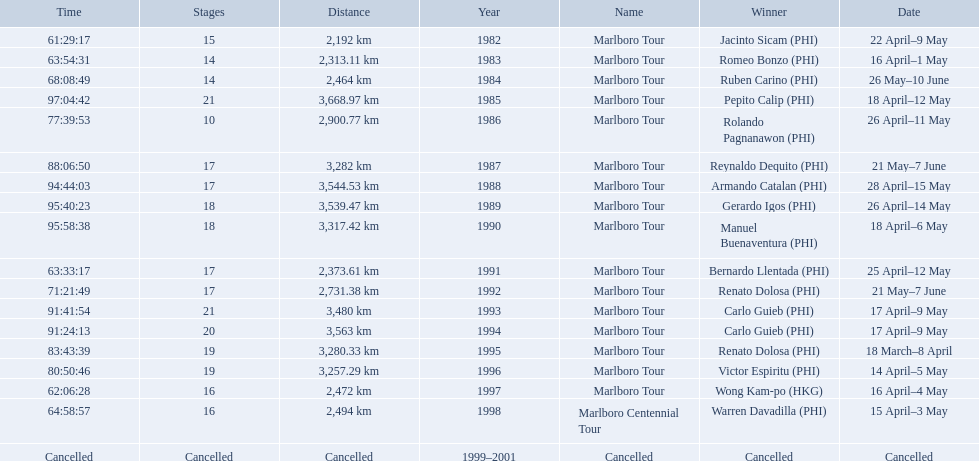What race did warren davadilla compete in in 1998? Marlboro Centennial Tour. Would you mind parsing the complete table? {'header': ['Time', 'Stages', 'Distance', 'Year', 'Name', 'Winner', 'Date'], 'rows': [['61:29:17', '15', '2,192\xa0km', '1982', 'Marlboro Tour', 'Jacinto Sicam\xa0(PHI)', '22 April–9 May'], ['63:54:31', '14', '2,313.11\xa0km', '1983', 'Marlboro Tour', 'Romeo Bonzo\xa0(PHI)', '16 April–1 May'], ['68:08:49', '14', '2,464\xa0km', '1984', 'Marlboro Tour', 'Ruben Carino\xa0(PHI)', '26 May–10 June'], ['97:04:42', '21', '3,668.97\xa0km', '1985', 'Marlboro Tour', 'Pepito Calip\xa0(PHI)', '18 April–12 May'], ['77:39:53', '10', '2,900.77\xa0km', '1986', 'Marlboro Tour', 'Rolando Pagnanawon\xa0(PHI)', '26 April–11 May'], ['88:06:50', '17', '3,282\xa0km', '1987', 'Marlboro Tour', 'Reynaldo Dequito\xa0(PHI)', '21 May–7 June'], ['94:44:03', '17', '3,544.53\xa0km', '1988', 'Marlboro Tour', 'Armando Catalan\xa0(PHI)', '28 April–15 May'], ['95:40:23', '18', '3,539.47\xa0km', '1989', 'Marlboro Tour', 'Gerardo Igos\xa0(PHI)', '26 April–14 May'], ['95:58:38', '18', '3,317.42\xa0km', '1990', 'Marlboro Tour', 'Manuel Buenaventura\xa0(PHI)', '18 April–6 May'], ['63:33:17', '17', '2,373.61\xa0km', '1991', 'Marlboro Tour', 'Bernardo Llentada\xa0(PHI)', '25 April–12 May'], ['71:21:49', '17', '2,731.38\xa0km', '1992', 'Marlboro Tour', 'Renato Dolosa\xa0(PHI)', '21 May–7 June'], ['91:41:54', '21', '3,480\xa0km', '1993', 'Marlboro Tour', 'Carlo Guieb\xa0(PHI)', '17 April–9 May'], ['91:24:13', '20', '3,563\xa0km', '1994', 'Marlboro Tour', 'Carlo Guieb\xa0(PHI)', '17 April–9 May'], ['83:43:39', '19', '3,280.33\xa0km', '1995', 'Marlboro Tour', 'Renato Dolosa\xa0(PHI)', '18 March–8 April'], ['80:50:46', '19', '3,257.29\xa0km', '1996', 'Marlboro Tour', 'Victor Espiritu\xa0(PHI)', '14 April–5 May'], ['62:06:28', '16', '2,472\xa0km', '1997', 'Marlboro Tour', 'Wong Kam-po\xa0(HKG)', '16 April–4 May'], ['64:58:57', '16', '2,494\xa0km', '1998', 'Marlboro Centennial Tour', 'Warren Davadilla\xa0(PHI)', '15 April–3 May'], ['Cancelled', 'Cancelled', 'Cancelled', '1999–2001', 'Cancelled', 'Cancelled', 'Cancelled']]} How long did it take davadilla to complete the marlboro centennial tour? 64:58:57. What are the distances travelled on the tour? 2,192 km, 2,313.11 km, 2,464 km, 3,668.97 km, 2,900.77 km, 3,282 km, 3,544.53 km, 3,539.47 km, 3,317.42 km, 2,373.61 km, 2,731.38 km, 3,480 km, 3,563 km, 3,280.33 km, 3,257.29 km, 2,472 km, 2,494 km. Which of these are the largest? 3,668.97 km. 